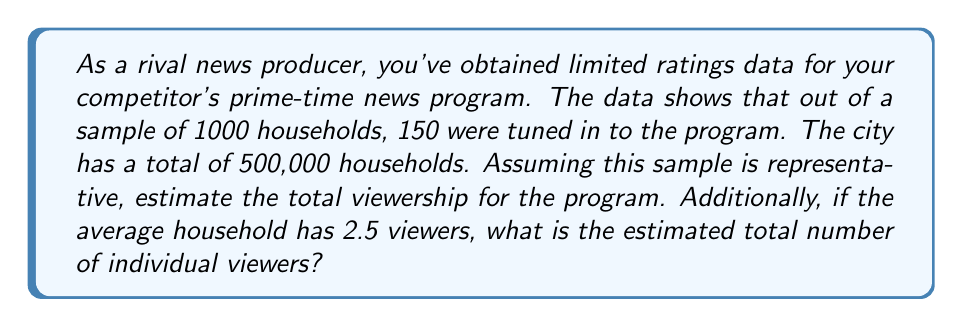Give your solution to this math problem. Let's approach this step-by-step:

1. Calculate the proportion of households watching in the sample:
   $p = \frac{150}{1000} = 0.15$ or 15%

2. Assuming this sample is representative, we can apply this proportion to the entire city:
   Total households watching = $500,000 \times 0.15 = 75,000$ households

3. To find the number of individual viewers, we multiply the number of households by the average number of viewers per household:
   Total viewers = $75,000 \times 2.5 = 187,500$

This problem demonstrates the inverse problem of estimating a population parameter (total viewership) from a sample statistic (ratings data). The key assumption here is that the sample is representative of the entire population, which allows us to extrapolate from the sample to the population.

The confidence in this estimate could be improved by:
- Increasing the sample size
- Ensuring the sample is truly random and representative
- Collecting data over multiple time periods

It's important to note that this is a point estimate and in practice, a confidence interval would provide a more robust understanding of the potential viewership range.
Answer: 75,000 households; 187,500 individual viewers 